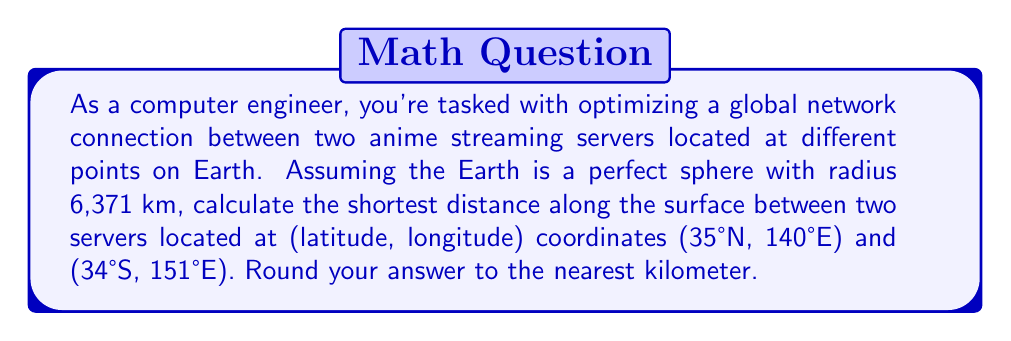Show me your answer to this math problem. To solve this problem, we'll use the great circle distance formula, which gives the shortest path between two points on a sphere. Here's the step-by-step solution:

1) Convert the latitudes and longitudes to radians:
   $\phi_1 = 35° \cdot \frac{\pi}{180} = 0.6109$ rad
   $\lambda_1 = 140° \cdot \frac{\pi}{180} = 2.4435$ rad
   $\phi_2 = -34° \cdot \frac{\pi}{180} = -0.5934$ rad
   $\lambda_2 = 151° \cdot \frac{\pi}{180} = 2.6355$ rad

2) Calculate the central angle $\Delta\sigma$ using the haversine formula:
   $$\Delta\sigma = 2 \arcsin\left(\sqrt{\sin^2\left(\frac{\phi_2-\phi_1}{2}\right) + \cos\phi_1 \cos\phi_2 \sin^2\left(\frac{\lambda_2-\lambda_1}{2}\right)}\right)$$

3) Substitute the values:
   $$\Delta\sigma = 2 \arcsin\left(\sqrt{\sin^2\left(\frac{-0.5934-0.6109}{2}\right) + \cos(0.6109) \cos(-0.5934) \sin^2\left(\frac{2.6355-2.4435}{2}\right)}\right)$$

4) Calculate:
   $\Delta\sigma \approx 1.9722$ rad

5) The distance $d$ along the great circle is given by:
   $d = R \cdot \Delta\sigma$
   where $R$ is the radius of the Earth (6,371 km)

6) Calculate the distance:
   $d = 6371 \cdot 1.9722 \approx 12565.08$ km

7) Round to the nearest kilometer:
   $d \approx 12565$ km
Answer: 12565 km 